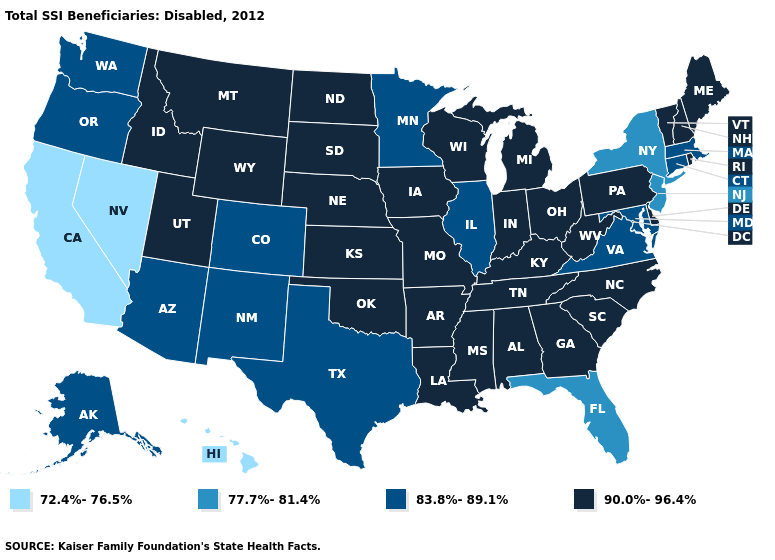Does Virginia have the highest value in the South?
Be succinct. No. What is the highest value in the USA?
Write a very short answer. 90.0%-96.4%. Does Kentucky have the lowest value in the South?
Write a very short answer. No. Among the states that border North Carolina , does Virginia have the lowest value?
Keep it brief. Yes. Which states have the lowest value in the USA?
Concise answer only. California, Hawaii, Nevada. What is the value of New Jersey?
Short answer required. 77.7%-81.4%. What is the highest value in states that border Texas?
Short answer required. 90.0%-96.4%. What is the lowest value in the USA?
Short answer required. 72.4%-76.5%. Name the states that have a value in the range 72.4%-76.5%?
Short answer required. California, Hawaii, Nevada. Does Pennsylvania have the lowest value in the Northeast?
Write a very short answer. No. Among the states that border Tennessee , which have the highest value?
Quick response, please. Alabama, Arkansas, Georgia, Kentucky, Mississippi, Missouri, North Carolina. What is the highest value in the USA?
Write a very short answer. 90.0%-96.4%. Which states have the lowest value in the South?
Concise answer only. Florida. Name the states that have a value in the range 72.4%-76.5%?
Write a very short answer. California, Hawaii, Nevada. What is the value of West Virginia?
Short answer required. 90.0%-96.4%. 